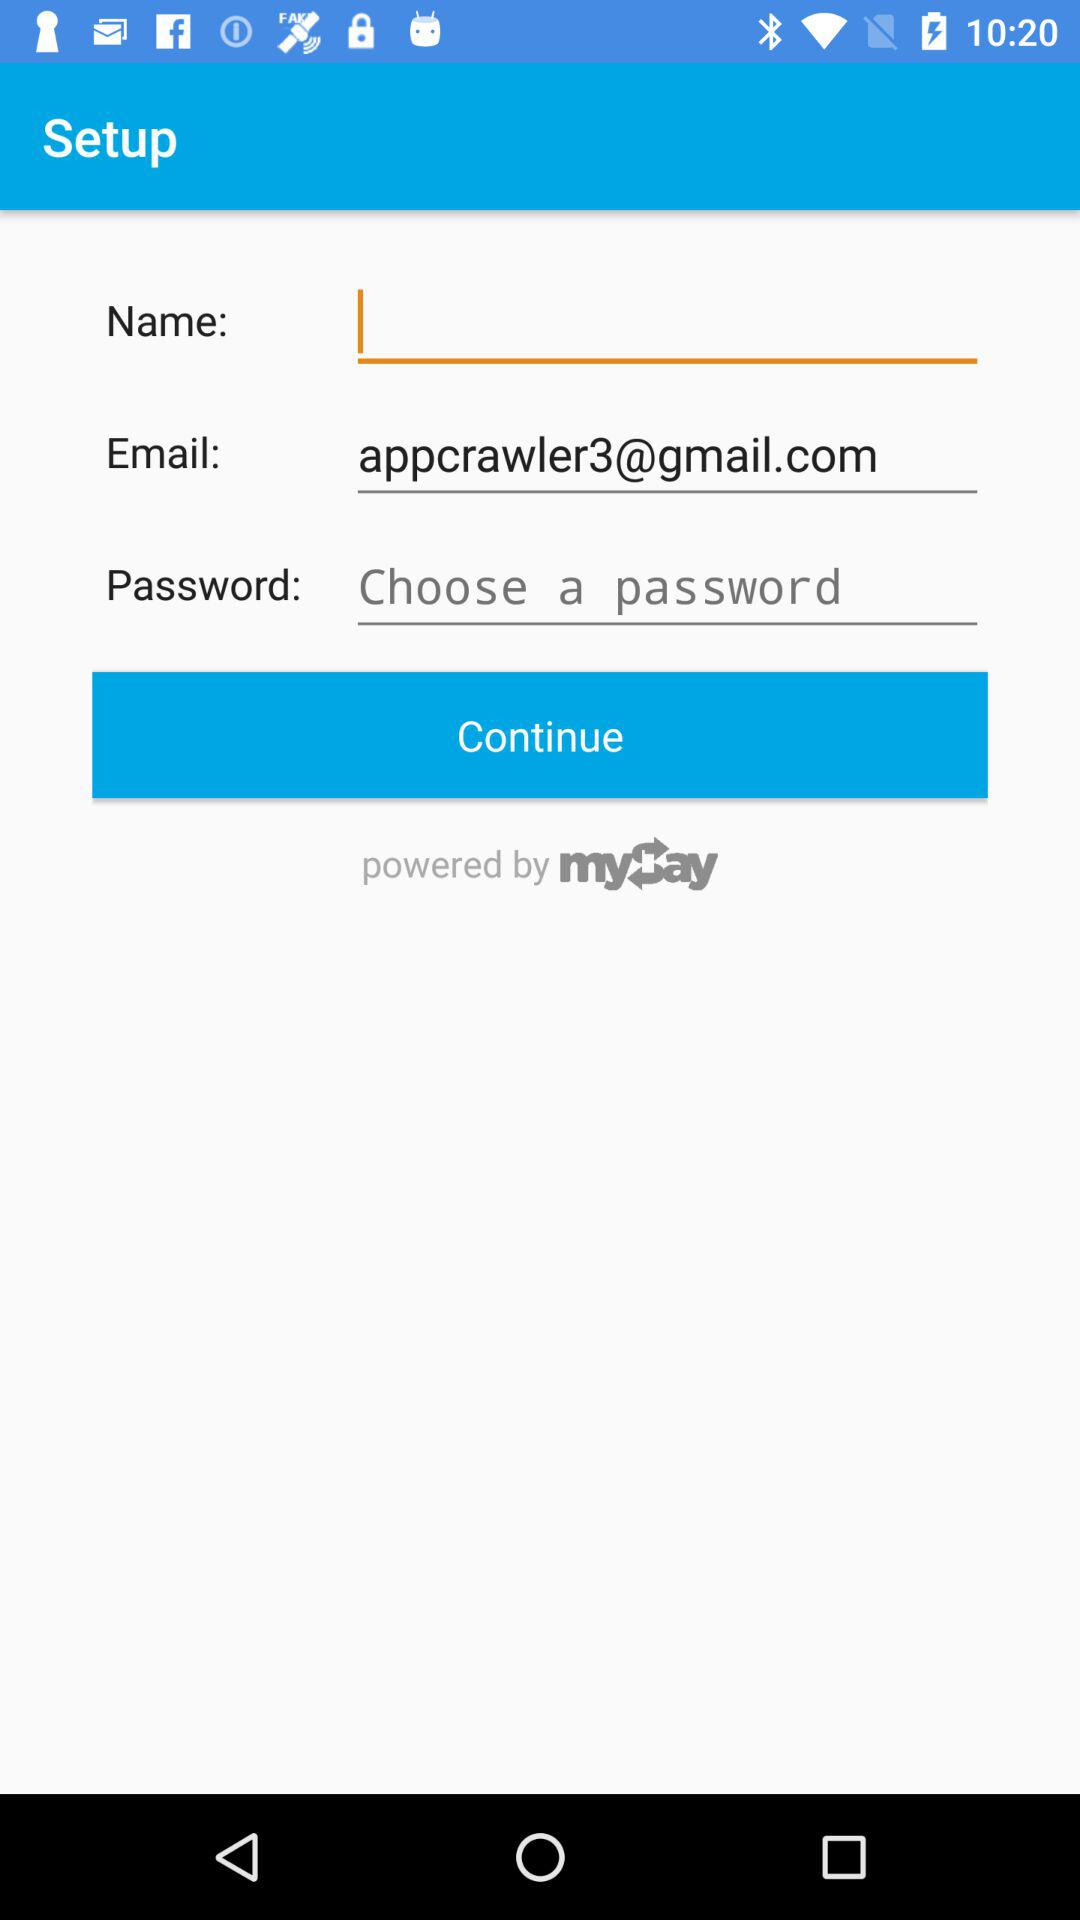What is the email address? The email address is "appcrawler3@gmail.com". 